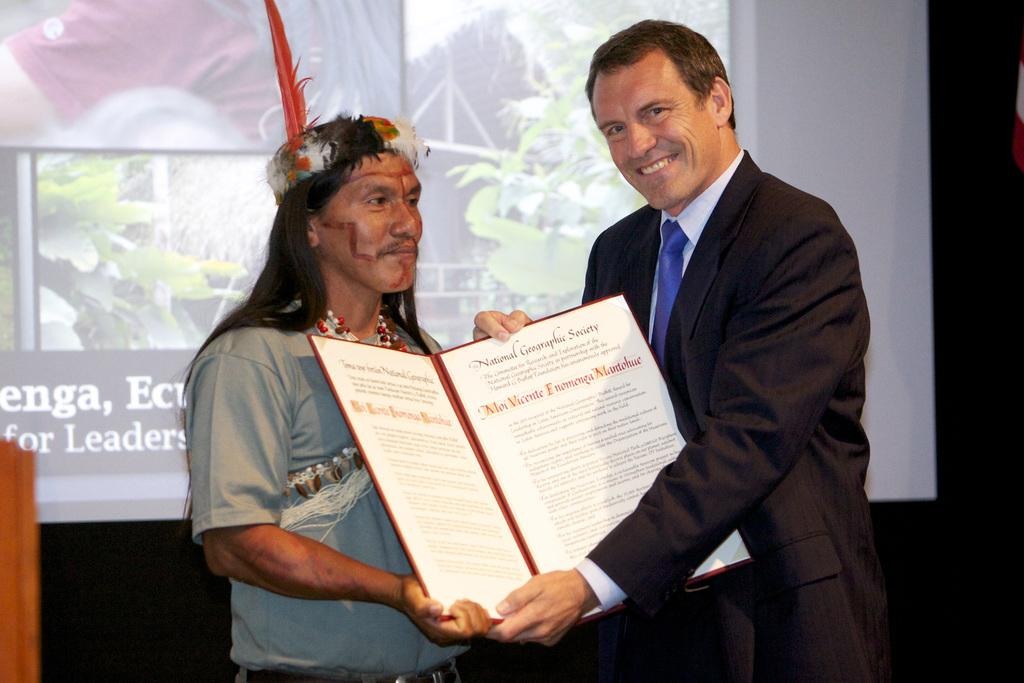How many people are in the image? There are two persons in the image. What are the two persons holding? The two persons are holding a card. Can you describe the clothing of one of the persons? One of the persons is wearing a blazer. What can be seen in the background of the image? There is a screen visible in the background of the image. What color is the grape that one of the persons is holding in the image? There is no grape present in the image; the two persons are holding a card. What type of spark can be seen coming from the screen in the background? There is no spark visible in the image; only a screen is present in the background. 